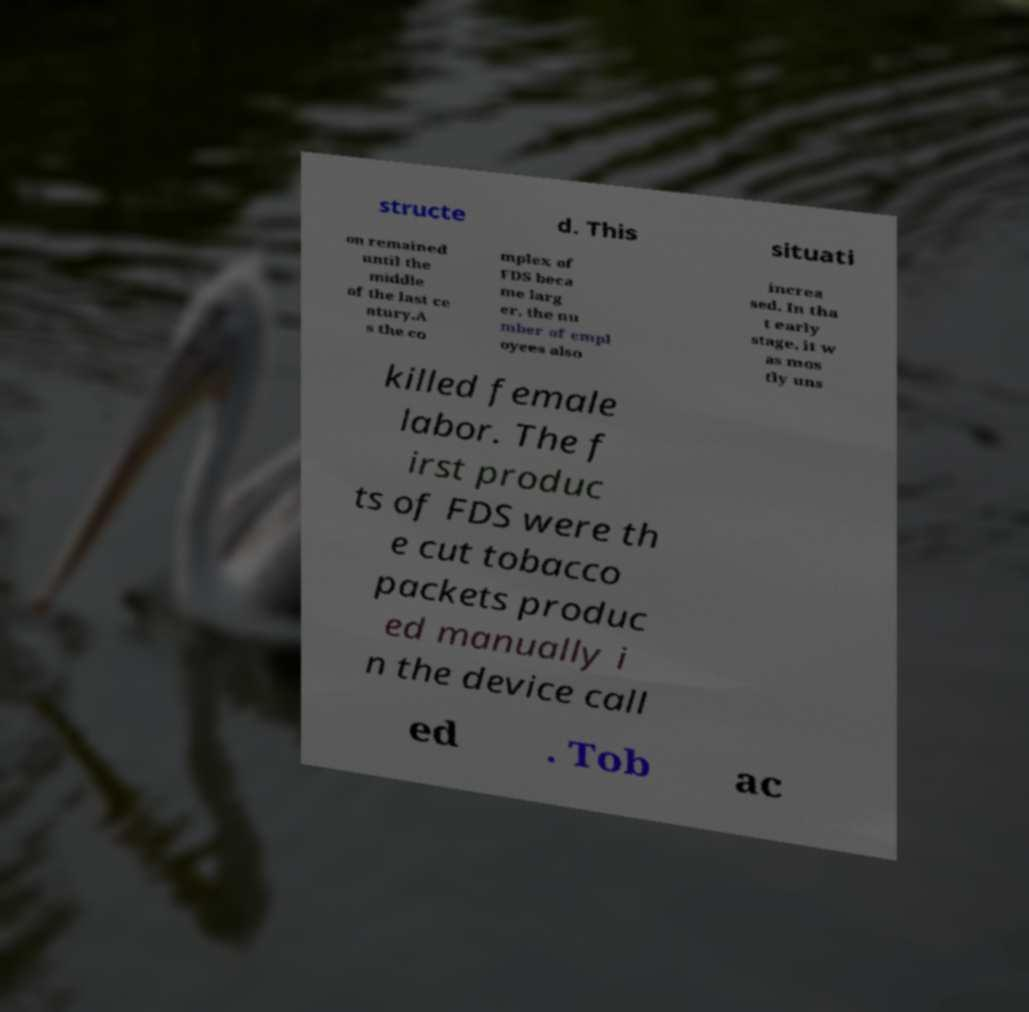Can you accurately transcribe the text from the provided image for me? structe d. This situati on remained until the middle of the last ce ntury.A s the co mplex of FDS beca me larg er, the nu mber of empl oyees also increa sed. In tha t early stage, it w as mos tly uns killed female labor. The f irst produc ts of FDS were th e cut tobacco packets produc ed manually i n the device call ed . Tob ac 